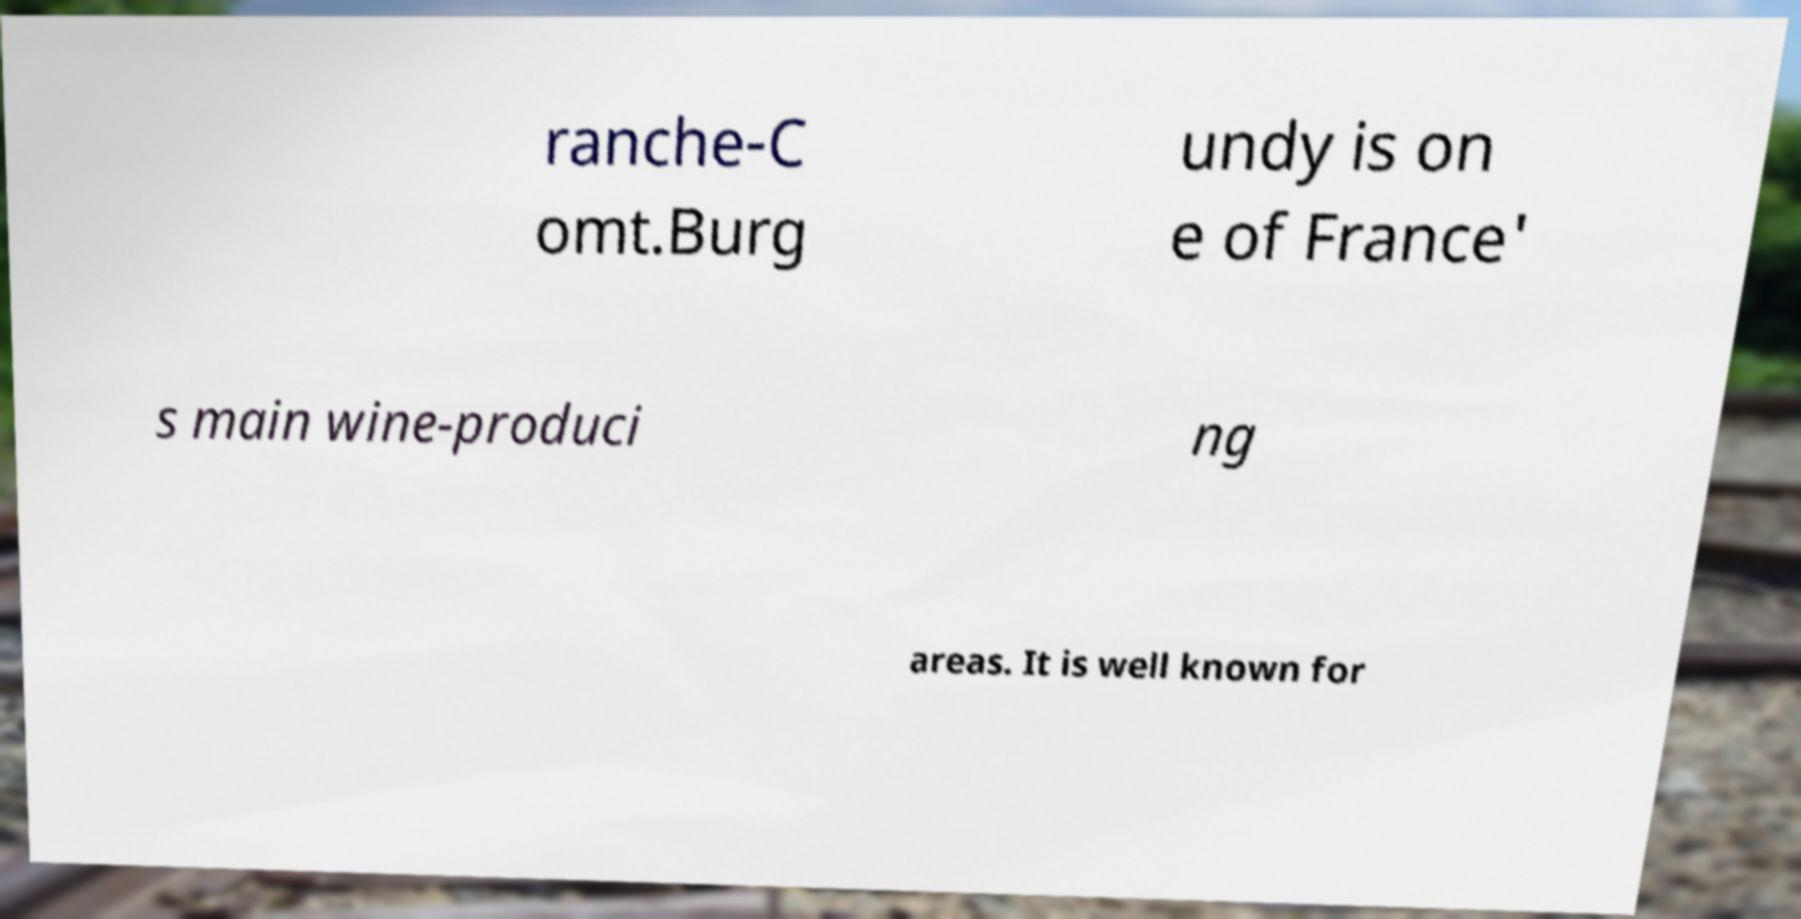Could you assist in decoding the text presented in this image and type it out clearly? ranche-C omt.Burg undy is on e of France' s main wine-produci ng areas. It is well known for 